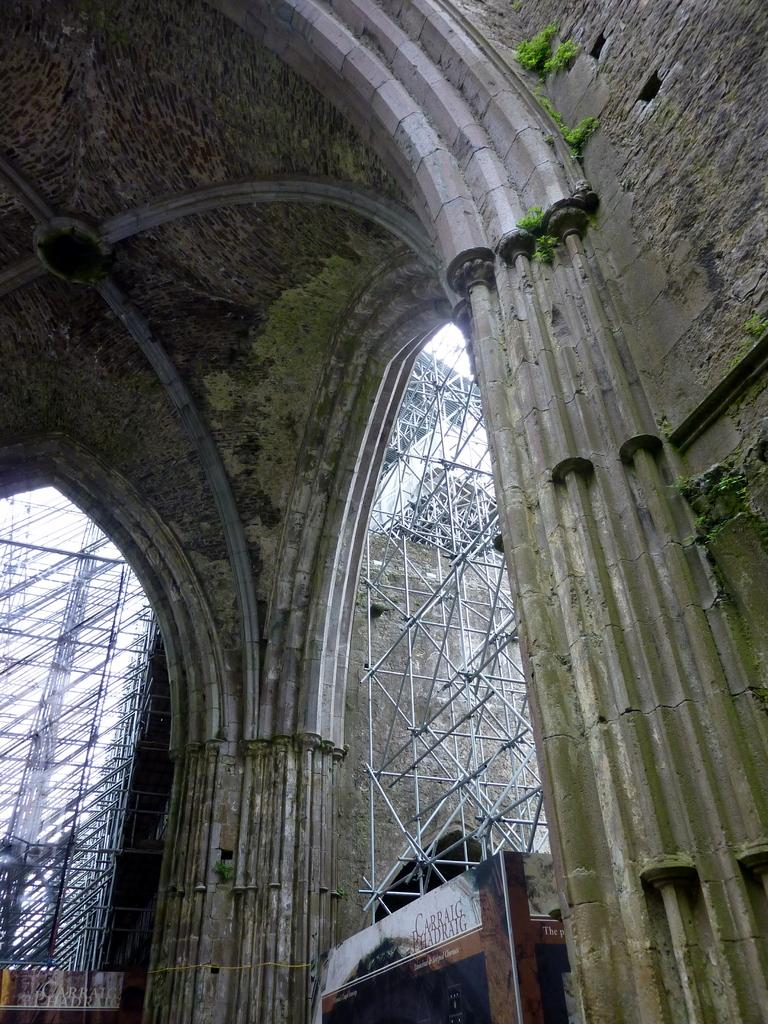What type of structure is present in the image? There is an architecture with a roof and pillars in the image. Can you describe the location of the structure? The architecture is near a wall in the image. What can be seen in the background of the image? There are towers and the sky visible in the background. What type of vegetables are being harvested in the image? There are no vegetables or harvesting activities present in the image. 